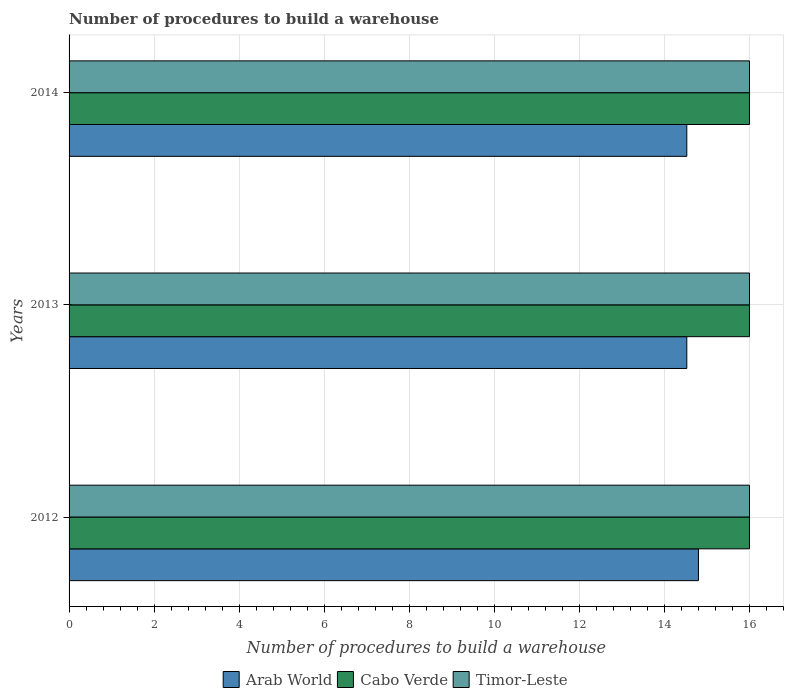Are the number of bars on each tick of the Y-axis equal?
Your answer should be compact. Yes. How many bars are there on the 2nd tick from the top?
Ensure brevity in your answer.  3. What is the number of procedures to build a warehouse in in Cabo Verde in 2013?
Keep it short and to the point. 16. Across all years, what is the maximum number of procedures to build a warehouse in in Cabo Verde?
Offer a very short reply. 16. Across all years, what is the minimum number of procedures to build a warehouse in in Arab World?
Your answer should be very brief. 14.53. In which year was the number of procedures to build a warehouse in in Cabo Verde minimum?
Offer a very short reply. 2012. What is the total number of procedures to build a warehouse in in Arab World in the graph?
Provide a succinct answer. 43.85. What is the difference between the number of procedures to build a warehouse in in Timor-Leste in 2014 and the number of procedures to build a warehouse in in Arab World in 2013?
Your answer should be compact. 1.47. What is the average number of procedures to build a warehouse in in Arab World per year?
Offer a terse response. 14.62. In the year 2012, what is the difference between the number of procedures to build a warehouse in in Cabo Verde and number of procedures to build a warehouse in in Timor-Leste?
Your response must be concise. 0. What is the ratio of the number of procedures to build a warehouse in in Timor-Leste in 2012 to that in 2013?
Offer a very short reply. 1. Is the number of procedures to build a warehouse in in Arab World in 2012 less than that in 2013?
Give a very brief answer. No. Is the difference between the number of procedures to build a warehouse in in Cabo Verde in 2012 and 2013 greater than the difference between the number of procedures to build a warehouse in in Timor-Leste in 2012 and 2013?
Make the answer very short. No. What is the difference between the highest and the lowest number of procedures to build a warehouse in in Arab World?
Give a very brief answer. 0.27. Is the sum of the number of procedures to build a warehouse in in Arab World in 2012 and 2014 greater than the maximum number of procedures to build a warehouse in in Cabo Verde across all years?
Offer a terse response. Yes. What does the 2nd bar from the top in 2014 represents?
Your response must be concise. Cabo Verde. What does the 3rd bar from the bottom in 2012 represents?
Offer a very short reply. Timor-Leste. Is it the case that in every year, the sum of the number of procedures to build a warehouse in in Timor-Leste and number of procedures to build a warehouse in in Cabo Verde is greater than the number of procedures to build a warehouse in in Arab World?
Your answer should be compact. Yes. Are all the bars in the graph horizontal?
Offer a very short reply. Yes. How many years are there in the graph?
Give a very brief answer. 3. What is the difference between two consecutive major ticks on the X-axis?
Offer a very short reply. 2. Are the values on the major ticks of X-axis written in scientific E-notation?
Make the answer very short. No. How many legend labels are there?
Provide a succinct answer. 3. What is the title of the graph?
Give a very brief answer. Number of procedures to build a warehouse. Does "Faeroe Islands" appear as one of the legend labels in the graph?
Keep it short and to the point. No. What is the label or title of the X-axis?
Your response must be concise. Number of procedures to build a warehouse. What is the Number of procedures to build a warehouse in Arab World in 2012?
Your response must be concise. 14.8. What is the Number of procedures to build a warehouse of Cabo Verde in 2012?
Keep it short and to the point. 16. What is the Number of procedures to build a warehouse in Arab World in 2013?
Provide a succinct answer. 14.53. What is the Number of procedures to build a warehouse of Cabo Verde in 2013?
Provide a succinct answer. 16. What is the Number of procedures to build a warehouse of Timor-Leste in 2013?
Provide a succinct answer. 16. What is the Number of procedures to build a warehouse of Arab World in 2014?
Keep it short and to the point. 14.53. What is the Number of procedures to build a warehouse in Timor-Leste in 2014?
Your response must be concise. 16. Across all years, what is the minimum Number of procedures to build a warehouse in Arab World?
Your answer should be very brief. 14.53. What is the total Number of procedures to build a warehouse in Arab World in the graph?
Keep it short and to the point. 43.85. What is the difference between the Number of procedures to build a warehouse in Arab World in 2012 and that in 2013?
Provide a succinct answer. 0.27. What is the difference between the Number of procedures to build a warehouse of Arab World in 2012 and that in 2014?
Ensure brevity in your answer.  0.27. What is the difference between the Number of procedures to build a warehouse of Timor-Leste in 2012 and that in 2014?
Give a very brief answer. 0. What is the difference between the Number of procedures to build a warehouse in Arab World in 2013 and that in 2014?
Offer a very short reply. 0. What is the difference between the Number of procedures to build a warehouse in Arab World in 2012 and the Number of procedures to build a warehouse in Cabo Verde in 2013?
Keep it short and to the point. -1.2. What is the difference between the Number of procedures to build a warehouse of Arab World in 2012 and the Number of procedures to build a warehouse of Cabo Verde in 2014?
Keep it short and to the point. -1.2. What is the difference between the Number of procedures to build a warehouse of Cabo Verde in 2012 and the Number of procedures to build a warehouse of Timor-Leste in 2014?
Your response must be concise. 0. What is the difference between the Number of procedures to build a warehouse of Arab World in 2013 and the Number of procedures to build a warehouse of Cabo Verde in 2014?
Make the answer very short. -1.47. What is the difference between the Number of procedures to build a warehouse in Arab World in 2013 and the Number of procedures to build a warehouse in Timor-Leste in 2014?
Keep it short and to the point. -1.47. What is the difference between the Number of procedures to build a warehouse of Cabo Verde in 2013 and the Number of procedures to build a warehouse of Timor-Leste in 2014?
Keep it short and to the point. 0. What is the average Number of procedures to build a warehouse of Arab World per year?
Make the answer very short. 14.62. What is the average Number of procedures to build a warehouse in Cabo Verde per year?
Ensure brevity in your answer.  16. In the year 2012, what is the difference between the Number of procedures to build a warehouse in Cabo Verde and Number of procedures to build a warehouse in Timor-Leste?
Your answer should be compact. 0. In the year 2013, what is the difference between the Number of procedures to build a warehouse of Arab World and Number of procedures to build a warehouse of Cabo Verde?
Provide a succinct answer. -1.47. In the year 2013, what is the difference between the Number of procedures to build a warehouse in Arab World and Number of procedures to build a warehouse in Timor-Leste?
Your answer should be compact. -1.47. In the year 2014, what is the difference between the Number of procedures to build a warehouse in Arab World and Number of procedures to build a warehouse in Cabo Verde?
Offer a very short reply. -1.47. In the year 2014, what is the difference between the Number of procedures to build a warehouse in Arab World and Number of procedures to build a warehouse in Timor-Leste?
Give a very brief answer. -1.47. In the year 2014, what is the difference between the Number of procedures to build a warehouse in Cabo Verde and Number of procedures to build a warehouse in Timor-Leste?
Make the answer very short. 0. What is the ratio of the Number of procedures to build a warehouse in Arab World in 2012 to that in 2013?
Make the answer very short. 1.02. What is the ratio of the Number of procedures to build a warehouse of Timor-Leste in 2012 to that in 2013?
Your answer should be compact. 1. What is the ratio of the Number of procedures to build a warehouse of Arab World in 2012 to that in 2014?
Your answer should be very brief. 1.02. What is the ratio of the Number of procedures to build a warehouse in Timor-Leste in 2012 to that in 2014?
Your response must be concise. 1. What is the ratio of the Number of procedures to build a warehouse of Arab World in 2013 to that in 2014?
Keep it short and to the point. 1. What is the ratio of the Number of procedures to build a warehouse in Timor-Leste in 2013 to that in 2014?
Keep it short and to the point. 1. What is the difference between the highest and the second highest Number of procedures to build a warehouse of Arab World?
Make the answer very short. 0.27. What is the difference between the highest and the second highest Number of procedures to build a warehouse in Cabo Verde?
Make the answer very short. 0. What is the difference between the highest and the second highest Number of procedures to build a warehouse of Timor-Leste?
Your answer should be compact. 0. What is the difference between the highest and the lowest Number of procedures to build a warehouse of Arab World?
Provide a succinct answer. 0.27. What is the difference between the highest and the lowest Number of procedures to build a warehouse in Cabo Verde?
Offer a very short reply. 0. What is the difference between the highest and the lowest Number of procedures to build a warehouse in Timor-Leste?
Offer a very short reply. 0. 